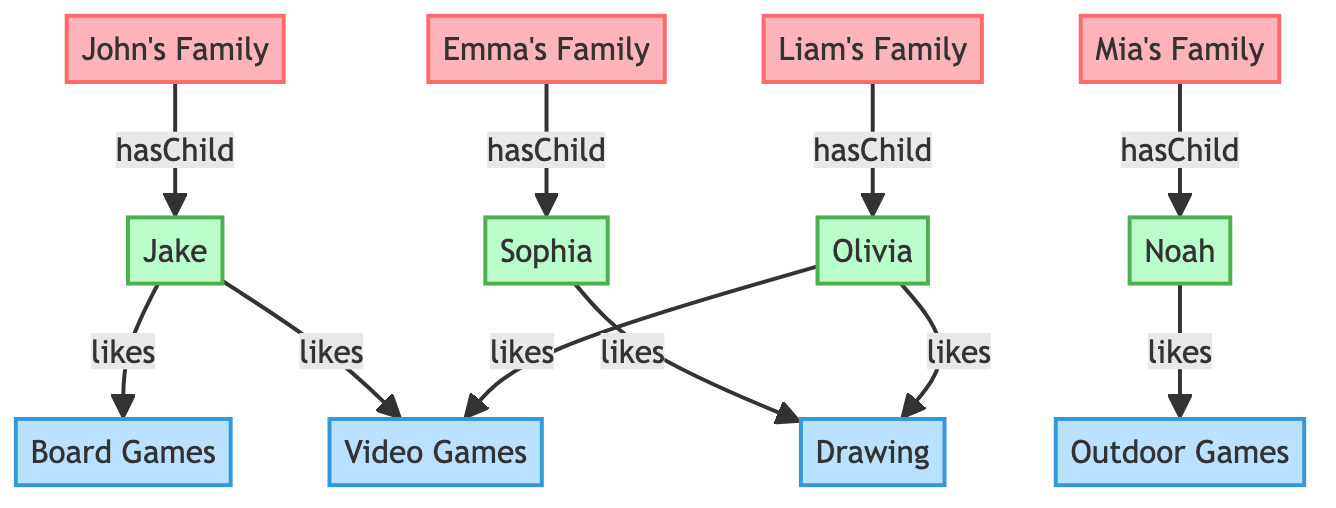What clients are represented in the diagram? The diagram includes four clients represented as nodes: John's Family, Emma's Family, Mia's Family, and Liam's Family.
Answer: John's Family, Emma's Family, Mia's Family, Liam's Family How many kids are shown in the diagram? The diagram features four kids: Jake, Sophia, Noah, and Olivia. Therefore, the count of kids is four.
Answer: 4 Which preference does Jake like? Examining the edges, Jake is connected to two preferences: Board Games and Video Games. Therefore, both are liked by him.
Answer: Board Games, Video Games Who likes Drawing? The node connections show that Sophia is the kid who likes Drawing, indicated by her edge to the Drawing preference.
Answer: Sophia Which family has a child that likes Outdoor Games? Looking at the relationships, Noah from Mia's Family is connected to the preference of Outdoor Games. Thus, Noah is identified as that child.
Answer: Mia's Family What is the relationship between Olivia and Video Games? Doubling back over the connections, Olivia has an edge indicating that she likes Video Games. This shows her relationship to this preference.
Answer: likes How many total preferences are illustrated in the diagram? The diagram displays four preferences indicated by the nodes for Board Games, Drawing, Outdoor Games, and Video Games. Therefore, the total number is four.
Answer: 4 Which child has the most preferences? By reviewing the connections, Olivia has two preferences (Drawing and Video Games) whereas others have either one or none; thus, the most preferences are linked to her.
Answer: Olivia Are there any children that like the same preferences? Upon review, both Jake and Olivia like Video Games, indicating they share this preference. Hence, the answer is yes.
Answer: Yes 